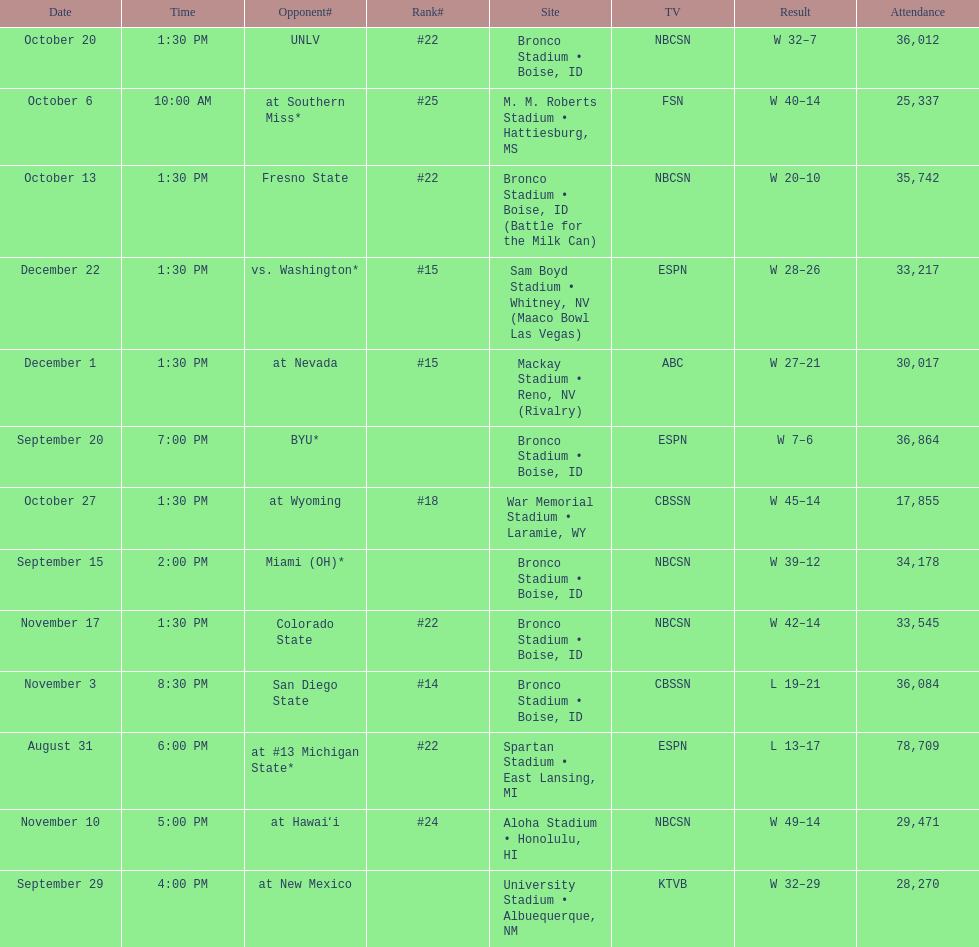What was there top ranked position of the season? #14. 